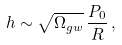<formula> <loc_0><loc_0><loc_500><loc_500>h \sim \sqrt { \Omega _ { g w } } \, \frac { P _ { 0 } } { R } \, ,</formula> 